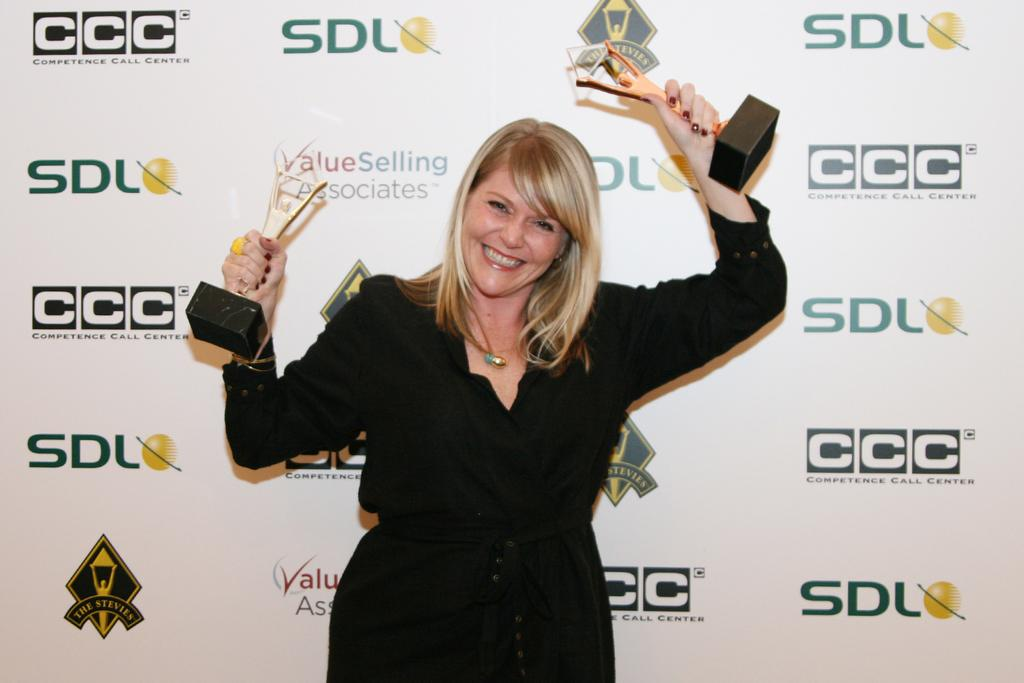What is the main subject of the image? The main subject of the image is a woman standing in the center. What is the woman holding in the image? The woman is holding mementos in the image. What can be seen in the background of the image? There is a board with text on it in the background of the image. What is the cause of the beggar's situation in the image? There is no beggar present in the image, so it is not possible to determine the cause of any situation related to a beggar. 